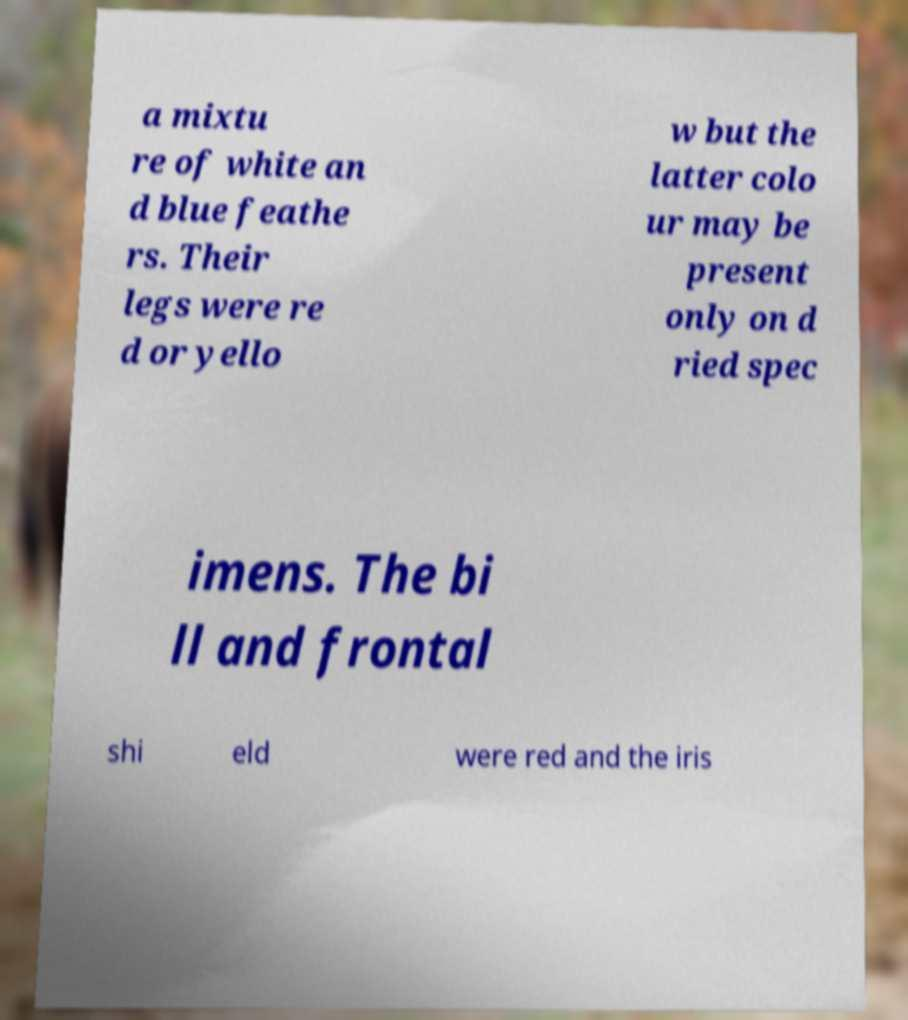There's text embedded in this image that I need extracted. Can you transcribe it verbatim? a mixtu re of white an d blue feathe rs. Their legs were re d or yello w but the latter colo ur may be present only on d ried spec imens. The bi ll and frontal shi eld were red and the iris 